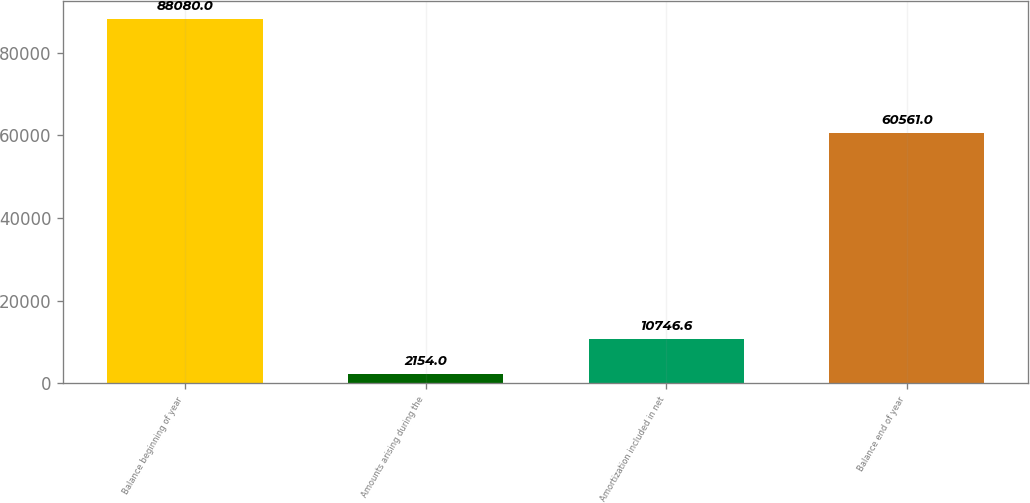<chart> <loc_0><loc_0><loc_500><loc_500><bar_chart><fcel>Balance beginning of year<fcel>Amounts arising during the<fcel>Amortization included in net<fcel>Balance end of year<nl><fcel>88080<fcel>2154<fcel>10746.6<fcel>60561<nl></chart> 